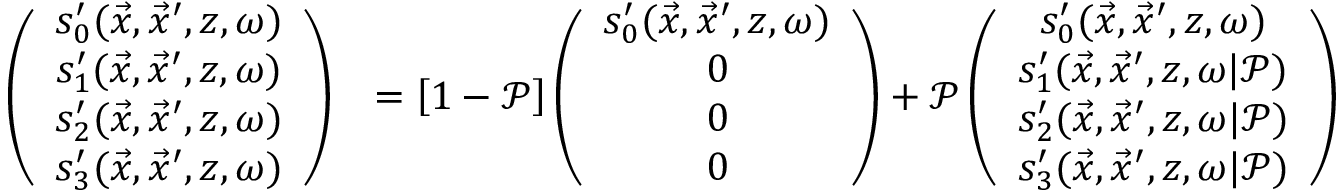<formula> <loc_0><loc_0><loc_500><loc_500>\begin{array} { r l } { \left ( \begin{array} { c } { s _ { 0 } ^ { \prime } ( \vec { x } , \vec { x } ^ { \prime } , z , \omega ) } \\ { s _ { 1 } ^ { \prime } ( \vec { x } , \vec { x } ^ { \prime } , z , \omega ) } \\ { s _ { 2 } ^ { \prime } ( \vec { x } , \vec { x } ^ { \prime } , z , \omega ) } \\ { s _ { 3 } ^ { \prime } ( \vec { x } , \vec { x } ^ { \prime } , z , \omega ) } \end{array} \right ) } & { = \left [ 1 - \mathcal { P } \right ] \left ( \begin{array} { c } { s _ { 0 } ^ { \prime } ( \vec { x } , \vec { x } ^ { \prime } , z , \omega ) } \\ { 0 } \\ { 0 } \\ { 0 } \end{array} \right ) + \mathcal { P } \left ( \begin{array} { c } { s _ { 0 } ^ { \prime } ( \vec { x } , \vec { x } ^ { \prime } , z , \omega ) } \\ { s _ { 1 } ^ { \prime } ( \vec { x } , \vec { x } ^ { \prime } , z , \omega | \mathcal { P } ) } \\ { s _ { 2 } ^ { \prime } ( \vec { x } , \vec { x } ^ { \prime } , z , \omega | \mathcal { P } ) } \\ { s _ { 3 } ^ { \prime } ( \vec { x } , \vec { x } ^ { \prime } , z , \omega | \mathcal { P } ) } \end{array} \right ) } \end{array}</formula> 